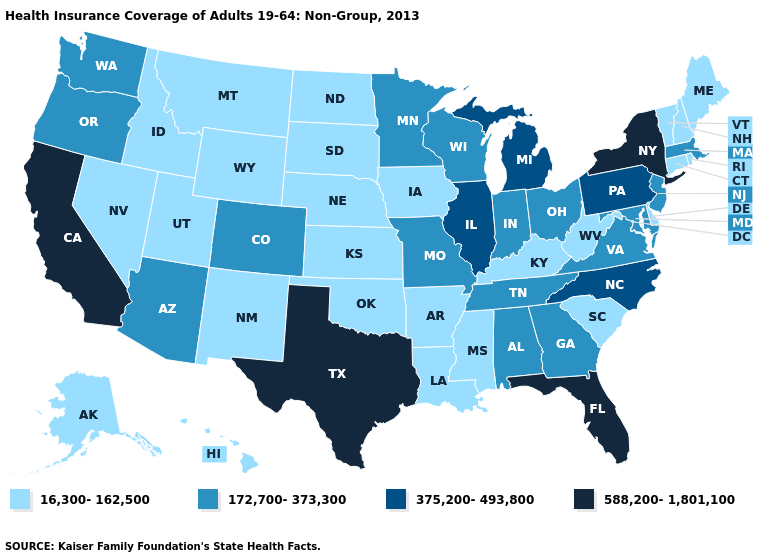Is the legend a continuous bar?
Quick response, please. No. What is the value of Virginia?
Answer briefly. 172,700-373,300. Does Florida have the lowest value in the South?
Short answer required. No. Is the legend a continuous bar?
Keep it brief. No. Does the map have missing data?
Keep it brief. No. What is the value of Colorado?
Be succinct. 172,700-373,300. Name the states that have a value in the range 588,200-1,801,100?
Quick response, please. California, Florida, New York, Texas. Does Nevada have a higher value than Massachusetts?
Write a very short answer. No. How many symbols are there in the legend?
Be succinct. 4. Which states have the highest value in the USA?
Short answer required. California, Florida, New York, Texas. Does the first symbol in the legend represent the smallest category?
Concise answer only. Yes. Name the states that have a value in the range 16,300-162,500?
Keep it brief. Alaska, Arkansas, Connecticut, Delaware, Hawaii, Idaho, Iowa, Kansas, Kentucky, Louisiana, Maine, Mississippi, Montana, Nebraska, Nevada, New Hampshire, New Mexico, North Dakota, Oklahoma, Rhode Island, South Carolina, South Dakota, Utah, Vermont, West Virginia, Wyoming. What is the lowest value in the Northeast?
Short answer required. 16,300-162,500. Which states have the lowest value in the USA?
Give a very brief answer. Alaska, Arkansas, Connecticut, Delaware, Hawaii, Idaho, Iowa, Kansas, Kentucky, Louisiana, Maine, Mississippi, Montana, Nebraska, Nevada, New Hampshire, New Mexico, North Dakota, Oklahoma, Rhode Island, South Carolina, South Dakota, Utah, Vermont, West Virginia, Wyoming. What is the highest value in the South ?
Short answer required. 588,200-1,801,100. 